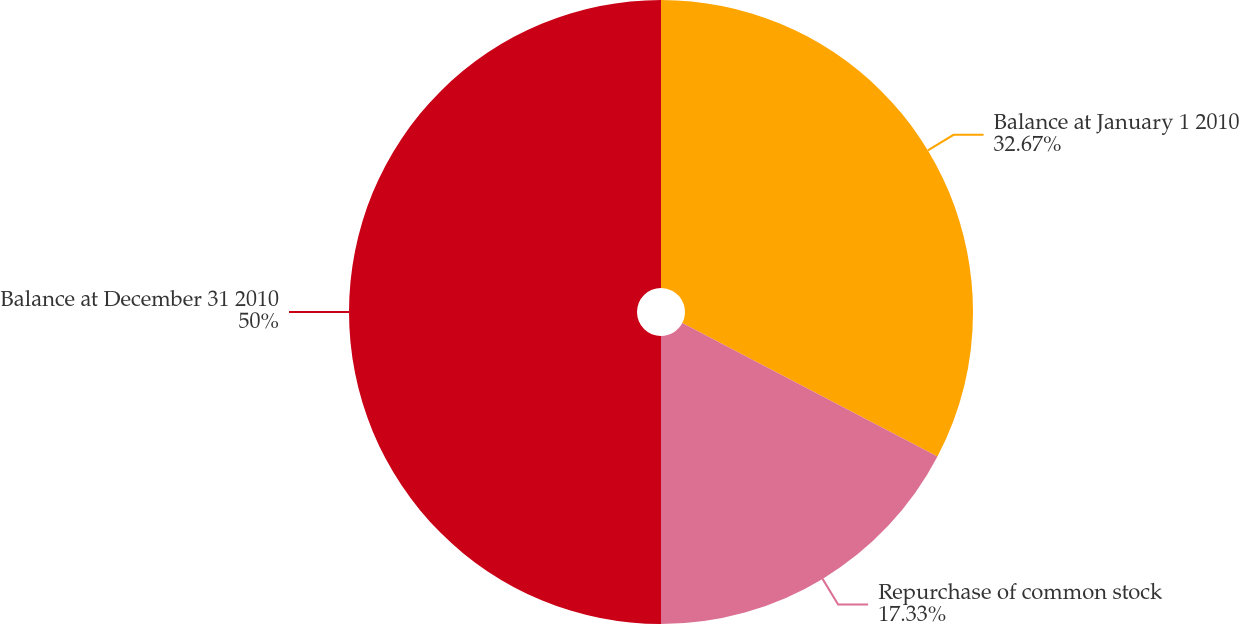<chart> <loc_0><loc_0><loc_500><loc_500><pie_chart><fcel>Balance at January 1 2010<fcel>Repurchase of common stock<fcel>Balance at December 31 2010<nl><fcel>32.67%<fcel>17.33%<fcel>50.0%<nl></chart> 